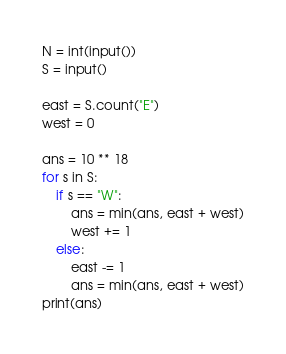<code> <loc_0><loc_0><loc_500><loc_500><_Python_>N = int(input())
S = input()

east = S.count("E")
west = 0

ans = 10 ** 18
for s in S:
    if s == "W":
        ans = min(ans, east + west)
        west += 1
    else:
        east -= 1
        ans = min(ans, east + west)
print(ans)</code> 